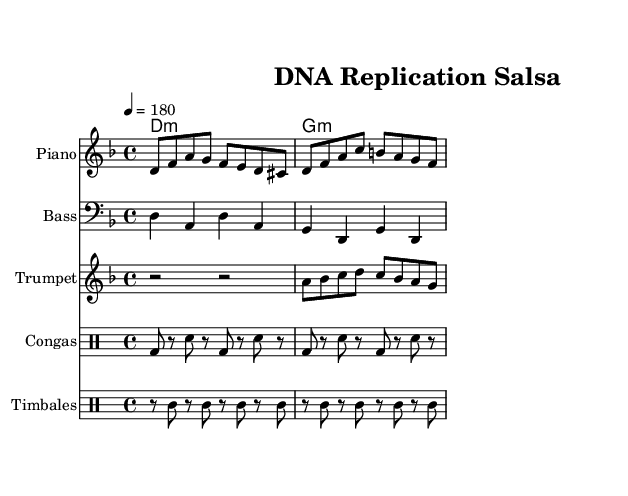What is the key signature of this music? The key signature shows two flats, indicating the piece is in D minor. In the upper left corner of the sheet music under the clef, we can see the notation that indicates the key.
Answer: D minor What is the time signature of this music? The time signature is found at the beginning of the staff. Here, it is represented as 4/4, indicating each measure has four beats, with a quarter note receiving one beat.
Answer: 4/4 What is the tempo marking of this music? The tempo marking is found above the staff and indicates the speed of the piece. It is indicated as "4 = 180," meaning there are 180 beats per minute.
Answer: 180 How many bars are in the piano part? By counting the measures in the piano staff from the beginning to the end, we observe there are a total of two bars, each divided into two smaller beats given the 4/4 time signature.
Answer: 2 What is the rhythm pattern for the congas? The conga rhythm is indicated in the drum staff using 'bd' for bass drum and 'sn' for snare. The pattern alternates between bass and snare with rests in between, revealing a clear rhythmic structure that is common in salsa music.
Answer: bd, sn Which instruments are used in this piece? The instruments are listed at the beginning of each staff. The piece includes piano, bass, trumpet, congas, and timbales, common in salsa music, creating a vibrant ensemble.
Answer: Piano, Bass, Trumpet, Congas, Timbales What chord is played throughout the piece? The chord progression is specified after the ChordNames line in the score, which shows a D minor chord followed by a G minor chord, commonly found in salsa music for creating a harmonic foundation.
Answer: D minor, G minor 